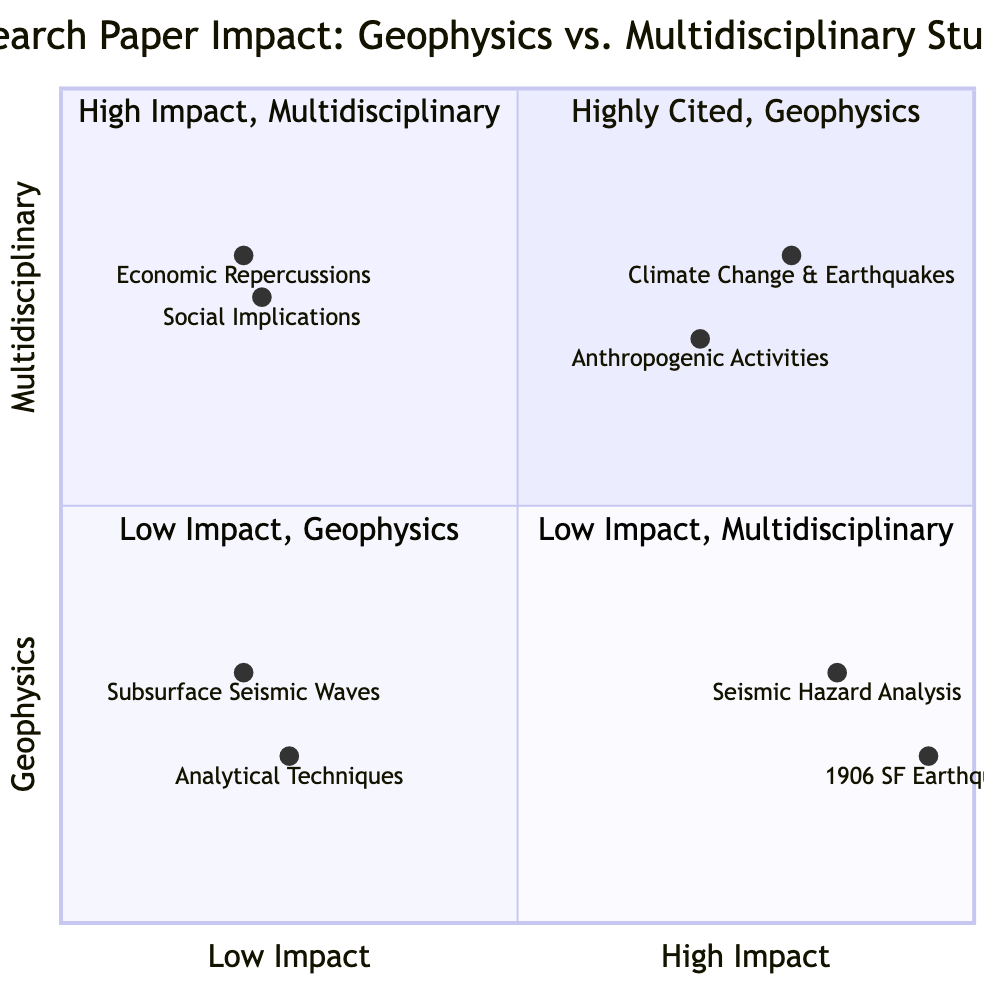What are the titles of the highly cited geophysics papers? The quadrant labeled "Highly Cited, Geophysics" includes two papers: "The 1906 San Francisco Earthquake: Macroseismic Investigation" and "Seismic Hazard Analysis for Critical Structures: A Review of Methodological Approaches."
Answer: "The 1906 San Francisco Earthquake: Macroseismic Investigation"; "Seismic Hazard Analysis for Critical Structures: A Review of Methodological Approaches" How many papers are in the low impact multidisciplinary quadrant? The quadrant labeled "Low Impact, Multidisciplinary" features two papers: "Social Implications of Earthquake Disasters: A Cultural Perspective" and "Economic Repercussions of Major Earthquakes: A Case Study in Japan."
Answer: 2 Which paper has the highest citations in the highly cited geophysics category? In the "Highly Cited, Geophysics" quadrant, "The 1906 San Francisco Earthquake: Macroseismic Investigation" has 15000 citations, which is the highest among the examples provided in this quadrant.
Answer: 15000 Is there any overlap between the types of studies in the high impact quadrant? The quadrant labeled "High Impact, Multidisciplinary" contains two distinct studies that focus on different aspects—climate change and anthropogenic activities—indicating that they cover separate topics within multidisciplinary studies with no overlap.
Answer: No What is the citation count of the "Climate Change and Earthquake Interactions" paper? In the "High Impact, Multidisciplinary" quadrant, the paper titled "Climate Change and Earthquake Interactions: A Comprehensive Review" has 7600 citations, reflecting its impact in the field.
Answer: 7600 Which quadrant has the lowest average citations? The "Low Impact, Multidisciplinary" quadrant, with papers averaging around 190 citations, has the lowest citation rates of all quadrants when compared to the other three.
Answer: Low Impact, Multidisciplinary Which study type has the highest paper count based on the examples provided? Based on the examples, both geophysics and multidisciplinary categories contain four papers combined, but since we grouped them into quadrants, they are equal. However, geophysics in the "Highly Cited" quadrant could suggest a higher representation of impactful studies.
Answer: Equal How many citations does the “Social Implications of Earthquake Disasters” paper have? The paper titled "Social Implications of Earthquake Disasters: A Cultural Perspective," located in the "Low Impact, Multidisciplinary" quadrant, has 200 citations.
Answer: 200 